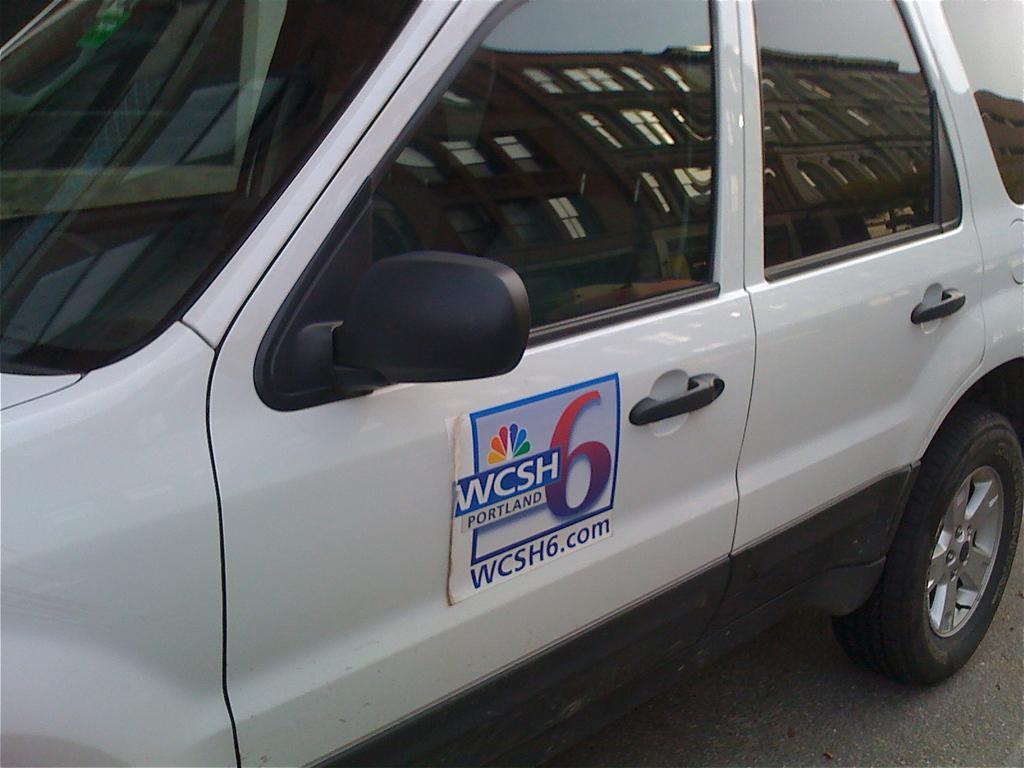What is the main subject of the image? The main subject of the image is a vehicle on the road. What is attached to the door of the vehicle? There is a poster with text attached to the door of the vehicle. Where is the mailbox located in the image? There is no mailbox present in the image. What type of plantation can be seen in the background of the image? There is no plantation visible in the image; it only features a vehicle on the road and a poster with text attached to the door. 